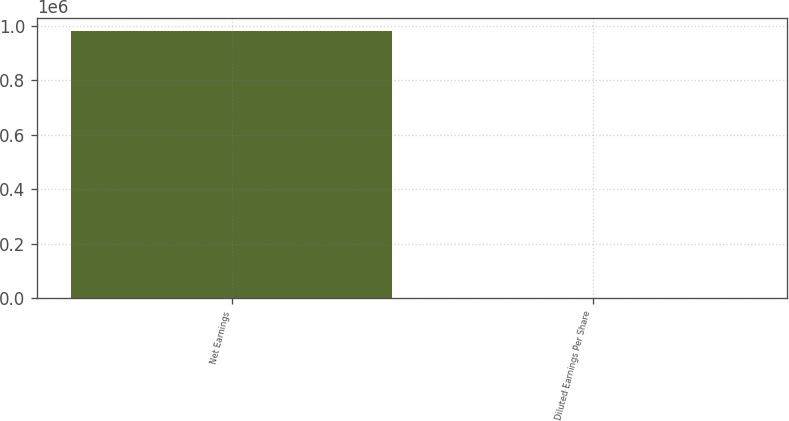Convert chart. <chart><loc_0><loc_0><loc_500><loc_500><bar_chart><fcel>Net Earnings<fcel>Diluted Earnings Per Share<nl><fcel>978806<fcel>1.8<nl></chart> 